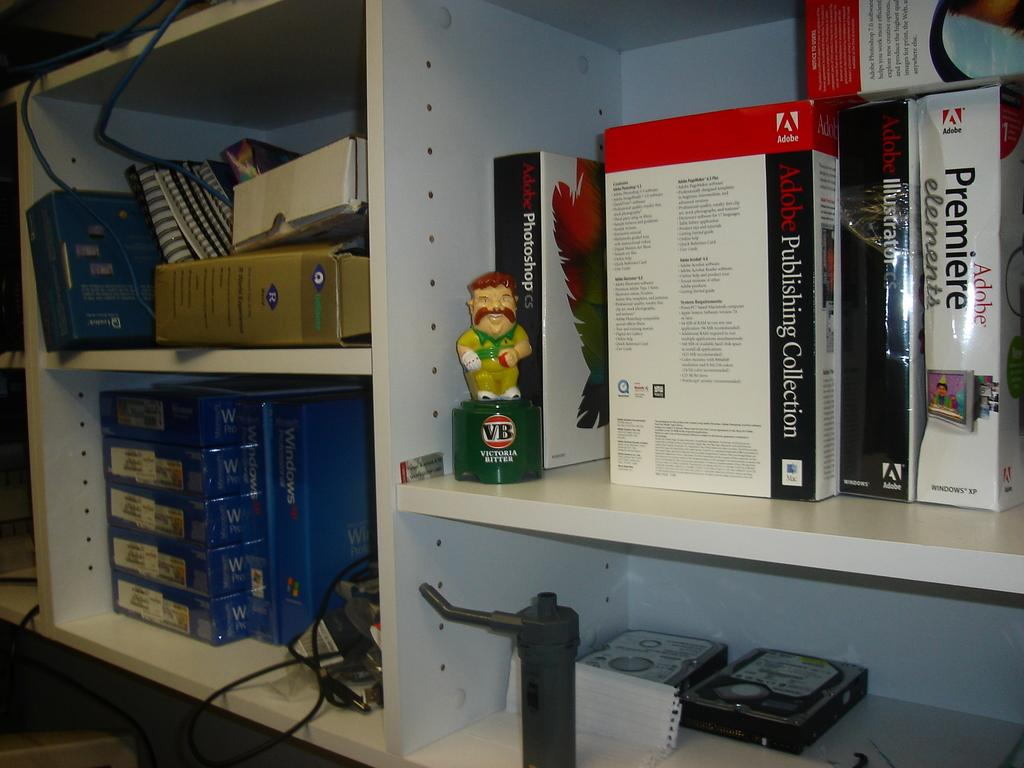<image>
Describe the image concisely. Shelves full of stuff including a figurine that says Victoria Bitter. 